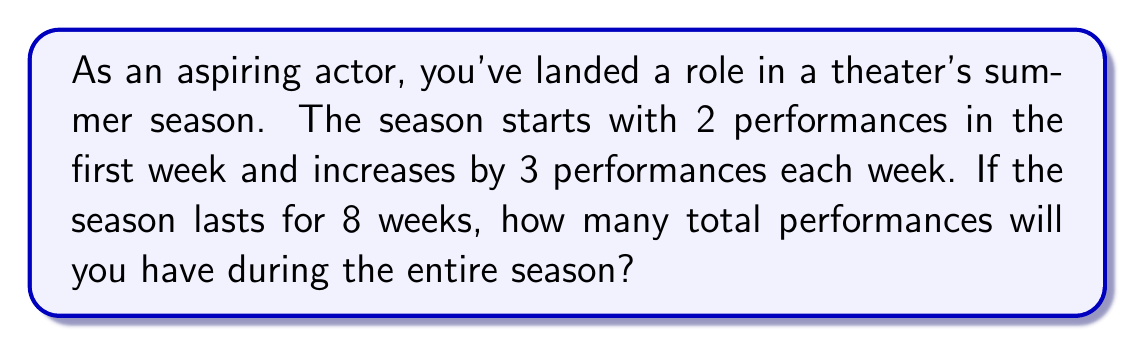Could you help me with this problem? Let's approach this step-by-step using arithmetic sequences:

1) First, we identify the components of our arithmetic sequence:
   - $a_1 = 2$ (first term, number of performances in the first week)
   - $d = 3$ (common difference, increase in performances each week)
   - $n = 8$ (number of terms, total weeks in the season)

2) We need to find the sum of this arithmetic sequence. The formula for the sum of an arithmetic sequence is:

   $$S_n = \frac{n}{2}(a_1 + a_n)$$

   Where $a_n$ is the last term of the sequence.

3) To find $a_n$, we use the formula:

   $$a_n = a_1 + (n-1)d$$

4) Let's calculate $a_8$:
   
   $$a_8 = 2 + (8-1)3 = 2 + 21 = 23$$

5) Now we can calculate the sum:

   $$S_8 = \frac{8}{2}(2 + 23) = 4(25) = 100$$

Therefore, there will be 100 total performances during the 8-week season.
Answer: 100 performances 